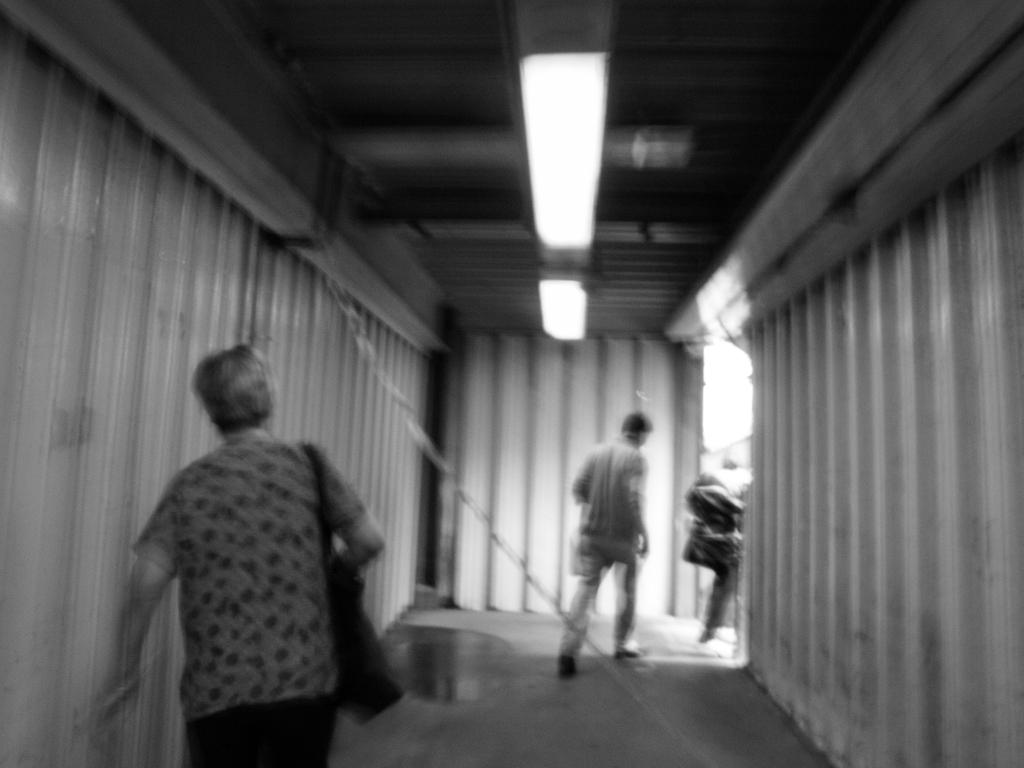What is the color scheme of the image? The image is black and white. What are the people in the image doing? The people are walking in the image. On what surface are the people walking? The people are walking on the floor. Where is the location of the image? The location is inside a tunnel. What can be seen at the top of the tunnel? There are lights at the top of the tunnel. What is present on the floor in the image? There is water on the floor. What type of foot design can be seen on the people walking in the image? There is no specific foot design mentioned or visible in the image; it is a black and white image of people walking in a tunnel with water on the floor. 